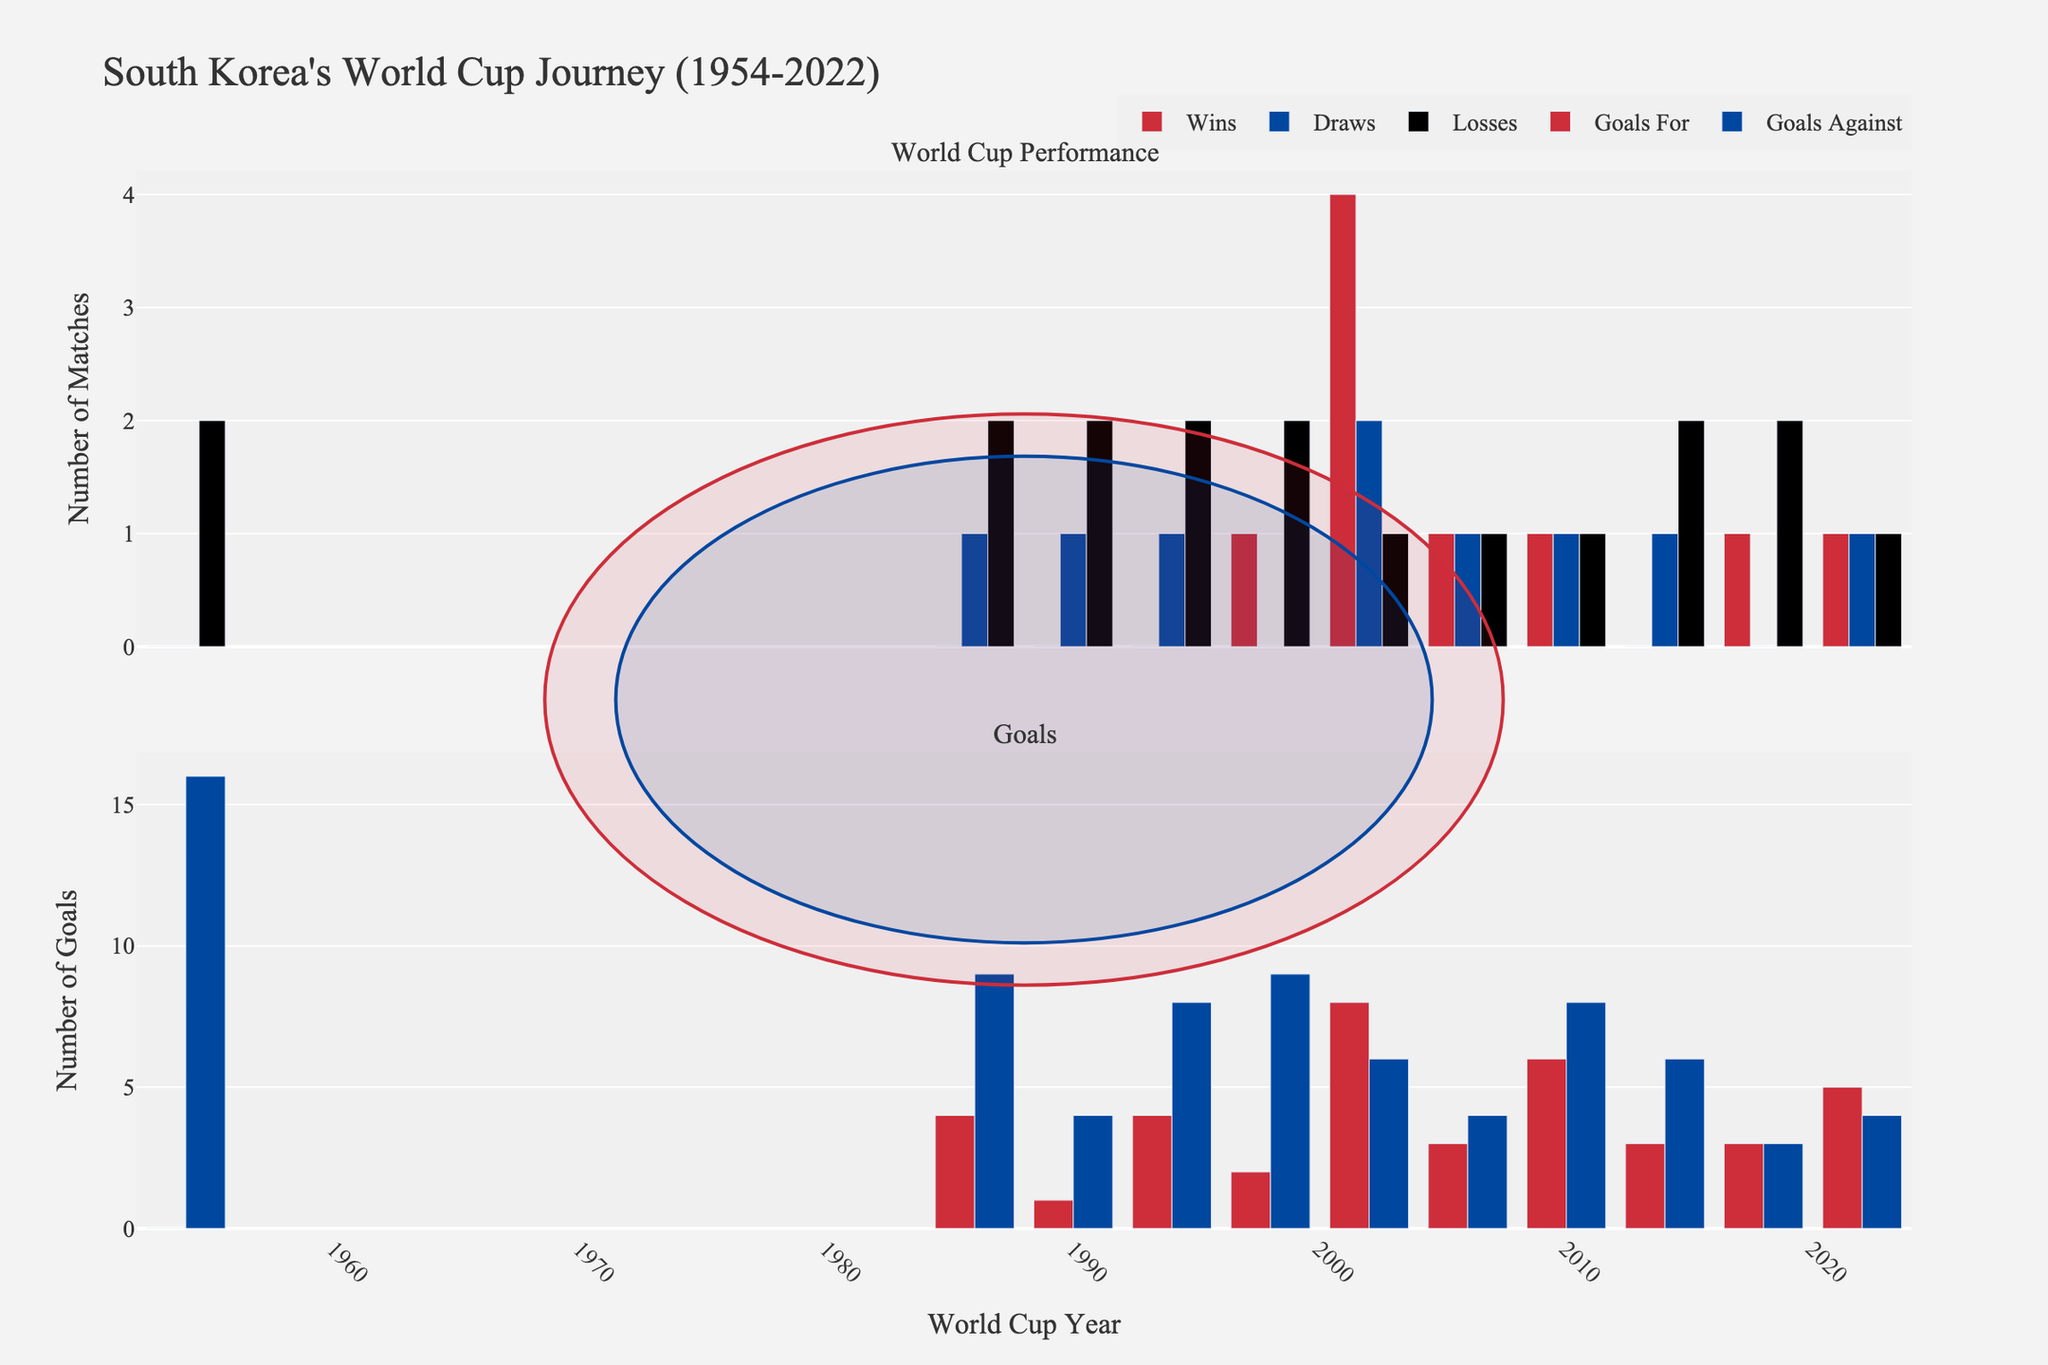What's the year with the highest number of wins in the World Cup for the South Korean national team? Look at the first subplot focusing on the "Wins" bar heights. The tallest bar corresponds to the year 2002.
Answer: 2002 Which year did South Korea have the highest goals against in the World Cup? Check the second subplot for "Goals Against" bar heights. The highest bar appears in 1954.
Answer: 1954 What is the total number of draws South Korea had in the World Cups between 1990 and 2010 inclusive? Sum up the "Draws" values for the years 1990, 1994, 1998, 2002, 2006, and 2010: 1+1+0+2+1+1 = 6
Answer: 6 In which World Cup did South Korea have more wins: 1998 or 2018? Compare the "Wins" bars for the years 1998 and 2018 in the first subplot. Both are 1, so they are equal.
Answer: Equal How does the number of goals scored in 1994 compare to the number of goals scored in 2014? Check the heights of the "Goals For" bars for 1994 and 2014 in the second subplot. In 1994, it's 4, and in 2014, it's 3, so 1994 is higher.
Answer: 1994 scored more What's the average number of losses for the South Korean team in World Cup appearances from 2002 to 2018? Sum the "Losses" values for the years 2002, 2006, 2010, 2014, and 2018: 1+1+1+2+2 = 7. The number of years is 5, so the average is 7/5 = 1.4
Answer: 1.4 Compare the total number of goals against for the periods 1986-1990 and 2014-2022. Add the "Goals Against" values for 1986 and 1990: 9+4=13. Add for 2014, 2018, and 2022: 6+3+4=13. Both periods have the same total.
Answer: Equal Did South Korea score more goals in 2006 or 2010? Compare the "Goals For" bar heights for 2006 and 2010. In 2006, it's 3, while in 2010, it's 6, so 2010 is higher.
Answer: 2010 What's the difference in the number of goals against between 1994 and 1998? Subtract the "Goals Against" in 1998 (9) from 1994 (8): 9 - 8 = 1
Answer: 1 How many more draws did South Korea have in 2002 compared to 2014? Subtract the "Draws" values for 2014 (1) from 2002 (2): 2 - 1 = 1
Answer: 1 